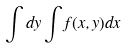<formula> <loc_0><loc_0><loc_500><loc_500>\int d y \int f ( x , y ) d x</formula> 